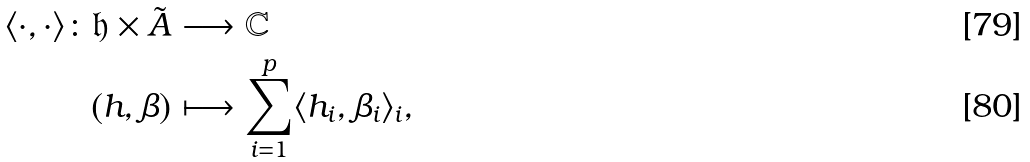Convert formula to latex. <formula><loc_0><loc_0><loc_500><loc_500>\langle \cdot , \cdot \rangle \colon \mathfrak { h } \times \tilde { A } & \longrightarrow \mathbb { C } \\ ( h , \beta ) & \longmapsto \sum _ { i = 1 } ^ { p } \langle h _ { i } , \beta _ { i } \rangle _ { i } ,</formula> 